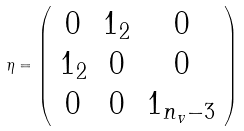<formula> <loc_0><loc_0><loc_500><loc_500>\eta = \left ( \begin{array} [ h ] { c c c } 0 & 1 _ { 2 } & 0 \\ 1 _ { 2 } & 0 & 0 \\ 0 & 0 & 1 _ { n _ { v } - 3 } \\ \end{array} \right )</formula> 